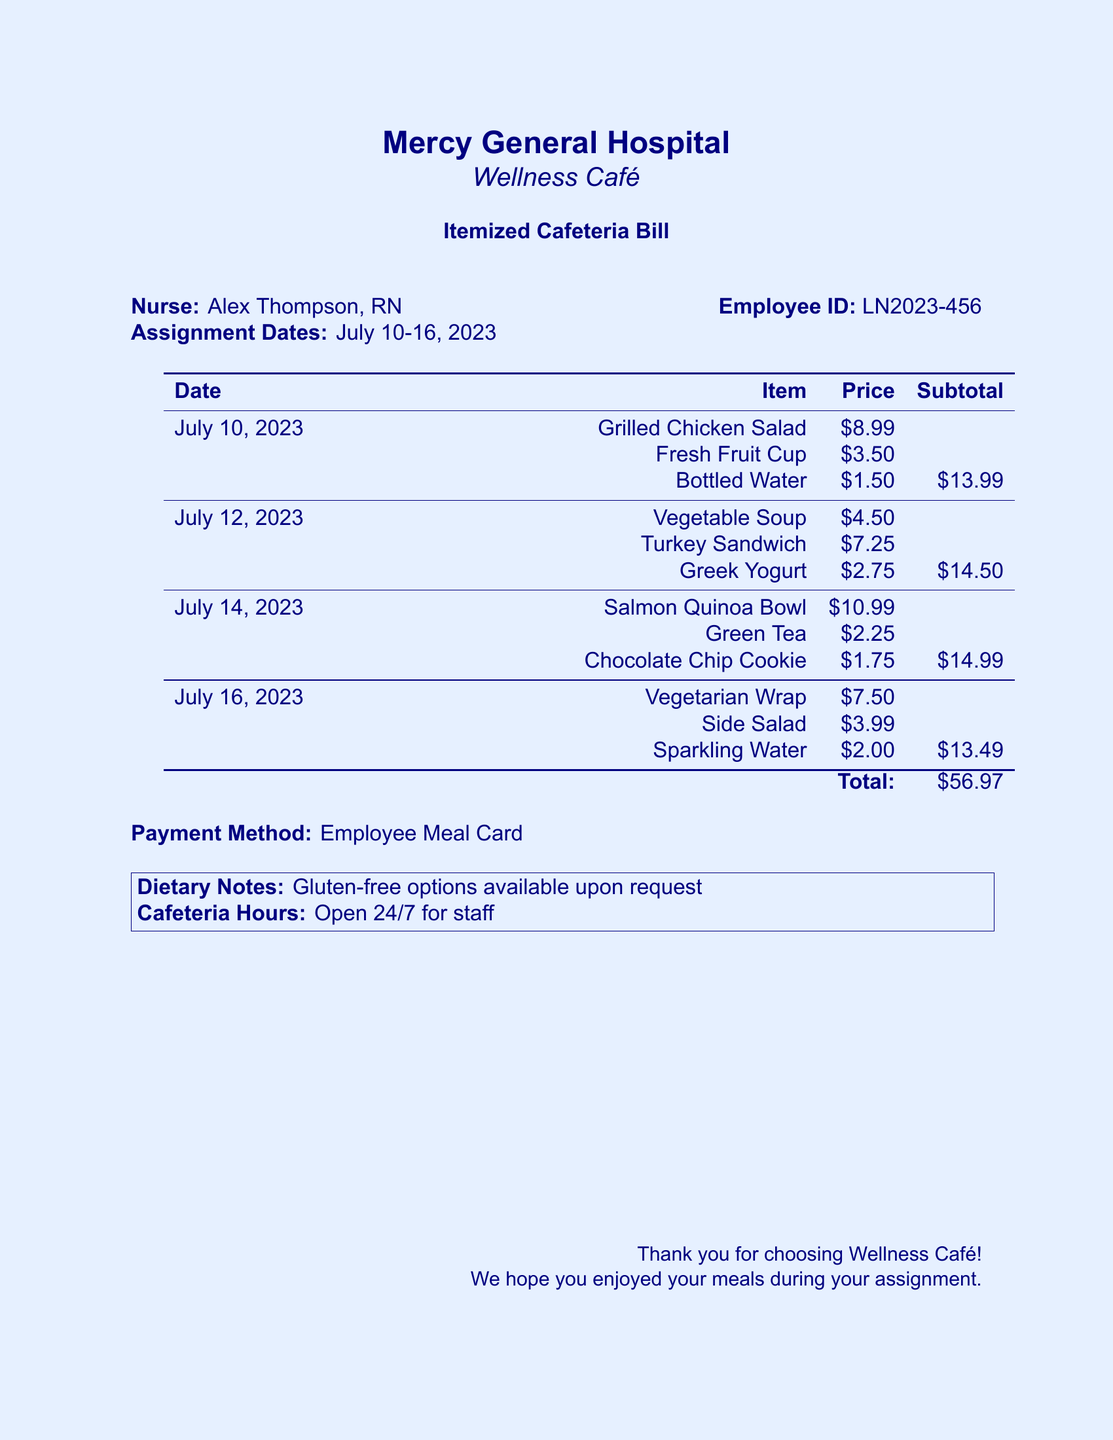What is the nurse's name? The nurse's name is listed clearly at the top of the document.
Answer: Alex Thompson What type of payment was used? The payment method is mentioned at the bottom of the document.
Answer: Employee Meal Card What was the total amount of the bill? The total amount is provided at the bottom of the table after all subtotals.
Answer: $56.97 On which date was the Salmon Quinoa Bowl purchased? The date for each item's purchase is listed alongside the items in the table.
Answer: July 14, 2023 How much was the Vegetable Soup? The price for each item is specified in the document under the corresponding item.
Answer: $4.50 What is the price of the Fresh Fruit Cup? The price for each item is listed in the table format making it easily retrievable.
Answer: $3.50 Which day had the highest subtotal for meals? Comparing the subtotals will reveal the day with the highest amount in the document.
Answer: July 12, 2023 How many meals were purchased on July 16, 2023? The number of items listed underneath each date shows how many meals were bought.
Answer: 3 Is there a note regarding dietary options? A note about dietary options is included in a specific section of the document.
Answer: Gluten-free options available upon request 